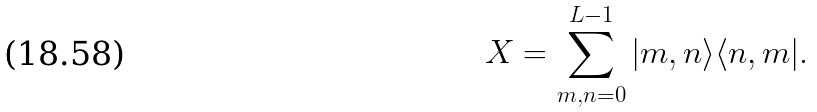<formula> <loc_0><loc_0><loc_500><loc_500>X = \sum _ { m , n = 0 } ^ { L - 1 } | m , n \rangle \langle n , m | .</formula> 